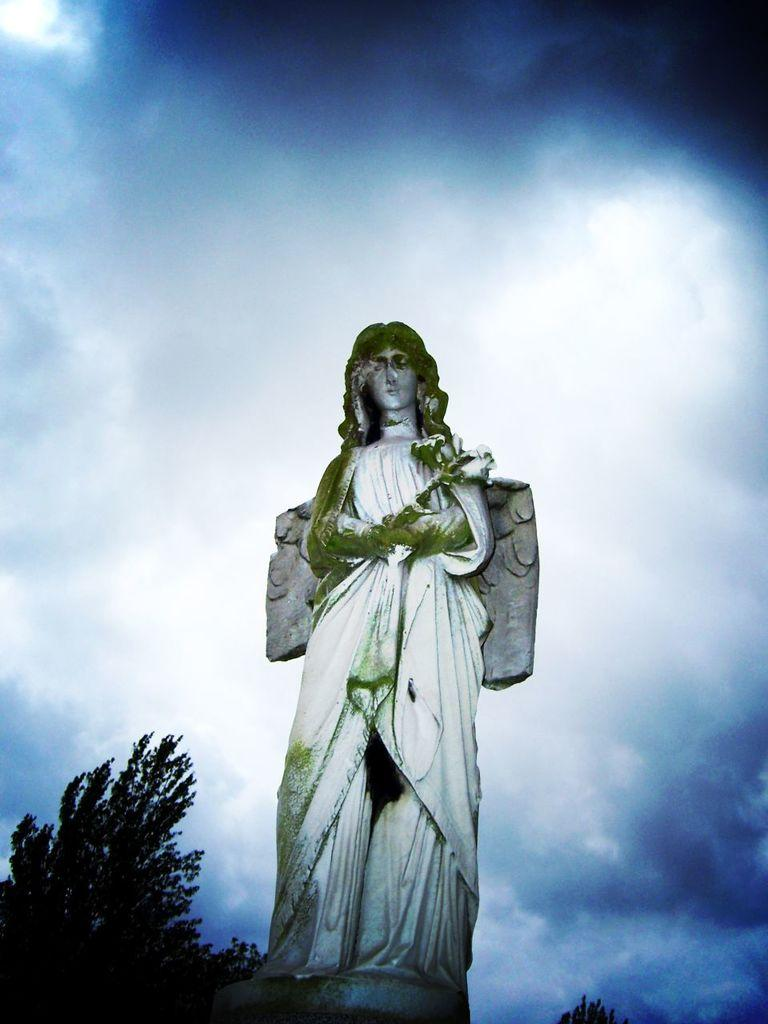Where was the picture taken? The picture was clicked outside. What is the main subject in the center of the image? There is a sculpture of a person in the center of the image. What is the person in the sculpture doing? The person in the sculpture is standing and holding an object. What type of natural environment can be seen in the image? There are trees visible in the image. What part of the natural environment is visible in the image? The sky is visible in the image. What other objects can be seen in the image besides the sculpture? There are other objects present in the image. What type of scent can be smelled coming from the net the rabbits in the image? There are no rabbits present in the image, and therefore no scent can be associated with them. 